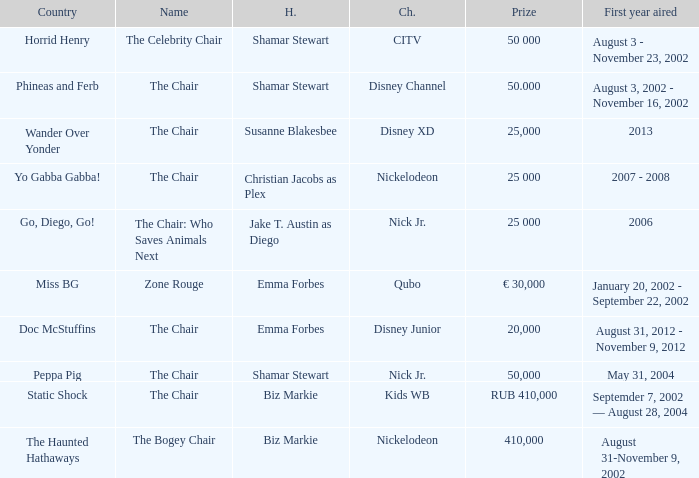Could you parse the entire table as a dict? {'header': ['Country', 'Name', 'H.', 'Ch.', 'Prize', 'First year aired'], 'rows': [['Horrid Henry', 'The Celebrity Chair', 'Shamar Stewart', 'CITV', '50 000', 'August 3 - November 23, 2002'], ['Phineas and Ferb', 'The Chair', 'Shamar Stewart', 'Disney Channel', '50.000', 'August 3, 2002 - November 16, 2002'], ['Wander Over Yonder', 'The Chair', 'Susanne Blakesbee', 'Disney XD', '25,000', '2013'], ['Yo Gabba Gabba!', 'The Chair', 'Christian Jacobs as Plex', 'Nickelodeon', '25 000', '2007 - 2008'], ['Go, Diego, Go!', 'The Chair: Who Saves Animals Next', 'Jake T. Austin as Diego', 'Nick Jr.', '25 000', '2006'], ['Miss BG', 'Zone Rouge', 'Emma Forbes', 'Qubo', '€ 30,000', 'January 20, 2002 - September 22, 2002'], ['Doc McStuffins', 'The Chair', 'Emma Forbes', 'Disney Junior', '20,000', 'August 31, 2012 - November 9, 2012'], ['Peppa Pig', 'The Chair', 'Shamar Stewart', 'Nick Jr.', '50,000', 'May 31, 2004'], ['Static Shock', 'The Chair', 'Biz Markie', 'Kids WB', 'RUB 410,000', 'Septemder 7, 2002 — August 28, 2004'], ['The Haunted Hathaways', 'The Bogey Chair', 'Biz Markie', 'Nickelodeon', '410,000', 'August 31-November 9, 2002']]} What year did Zone Rouge first air? January 20, 2002 - September 22, 2002. 